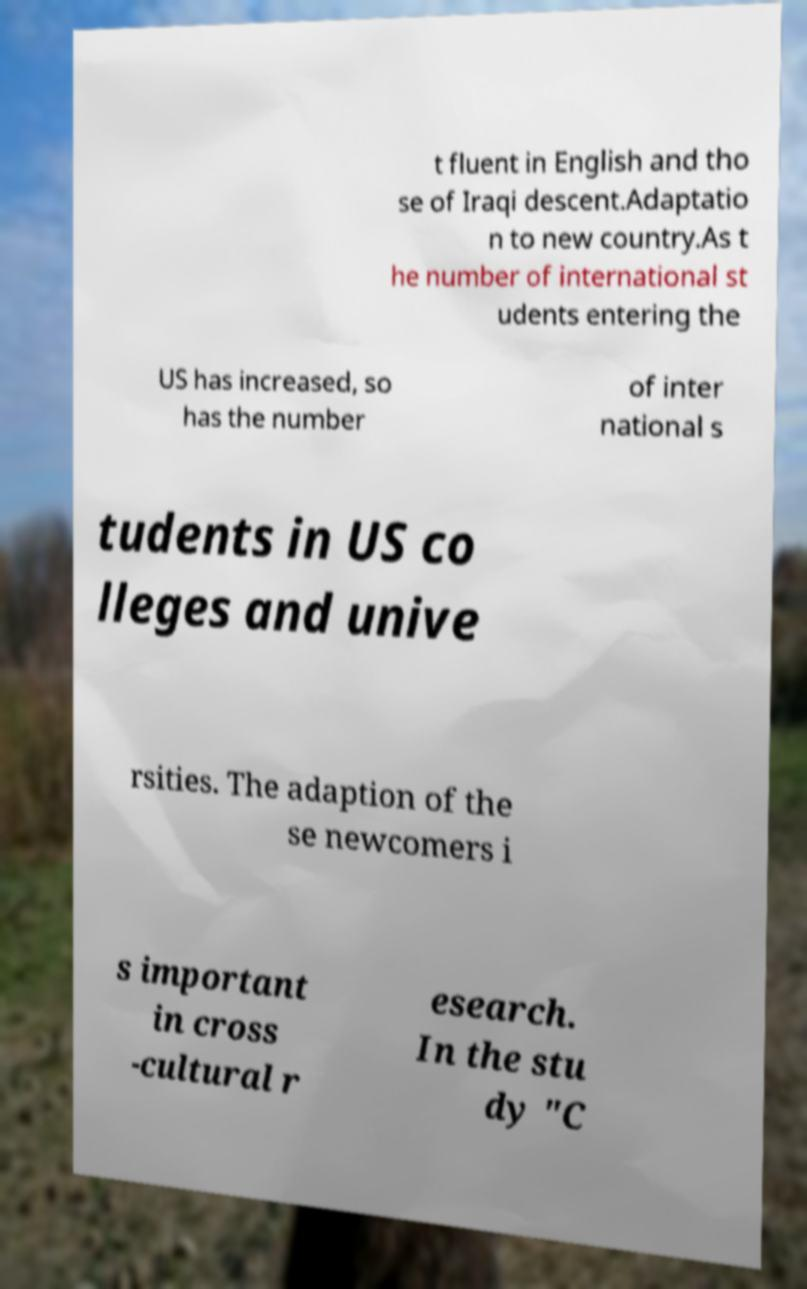Please identify and transcribe the text found in this image. t fluent in English and tho se of Iraqi descent.Adaptatio n to new country.As t he number of international st udents entering the US has increased, so has the number of inter national s tudents in US co lleges and unive rsities. The adaption of the se newcomers i s important in cross -cultural r esearch. In the stu dy "C 